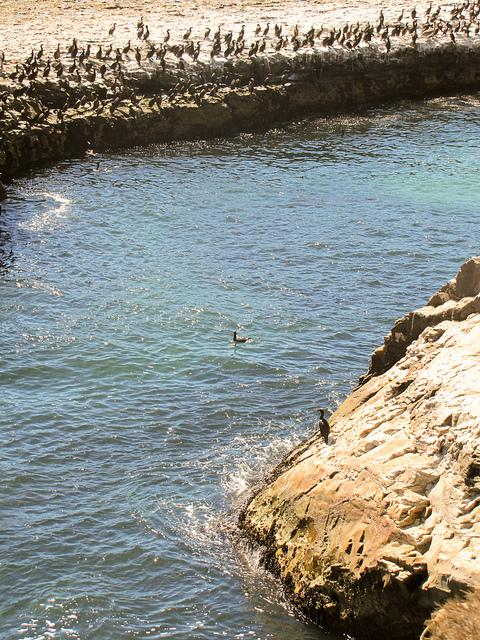What surface are all the birds standing on next to the big river? rocks 